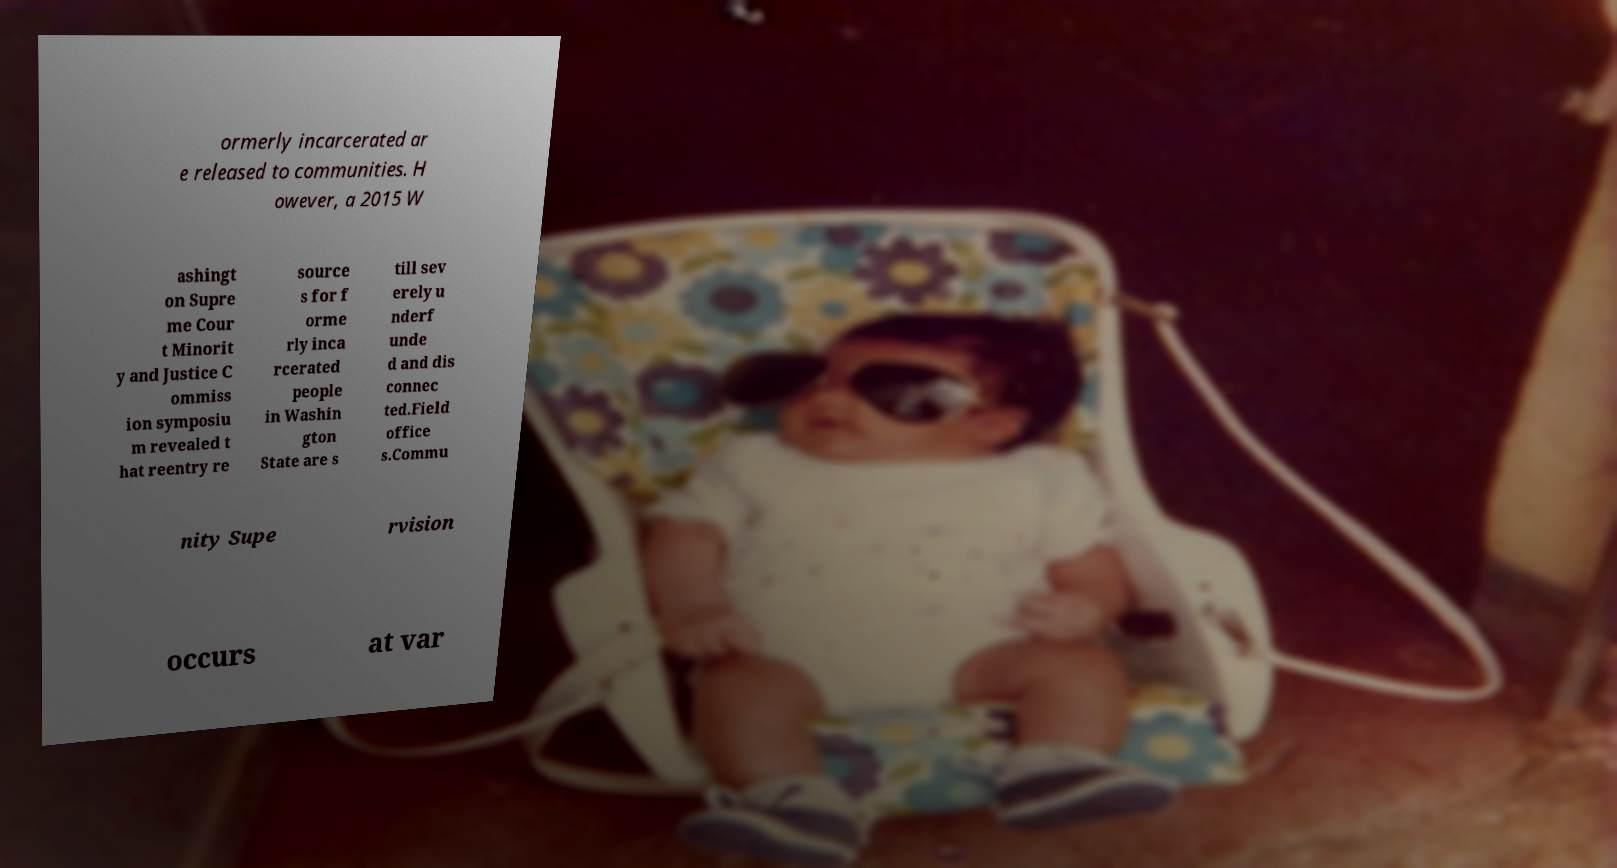For documentation purposes, I need the text within this image transcribed. Could you provide that? ormerly incarcerated ar e released to communities. H owever, a 2015 W ashingt on Supre me Cour t Minorit y and Justice C ommiss ion symposiu m revealed t hat reentry re source s for f orme rly inca rcerated people in Washin gton State are s till sev erely u nderf unde d and dis connec ted.Field office s.Commu nity Supe rvision occurs at var 